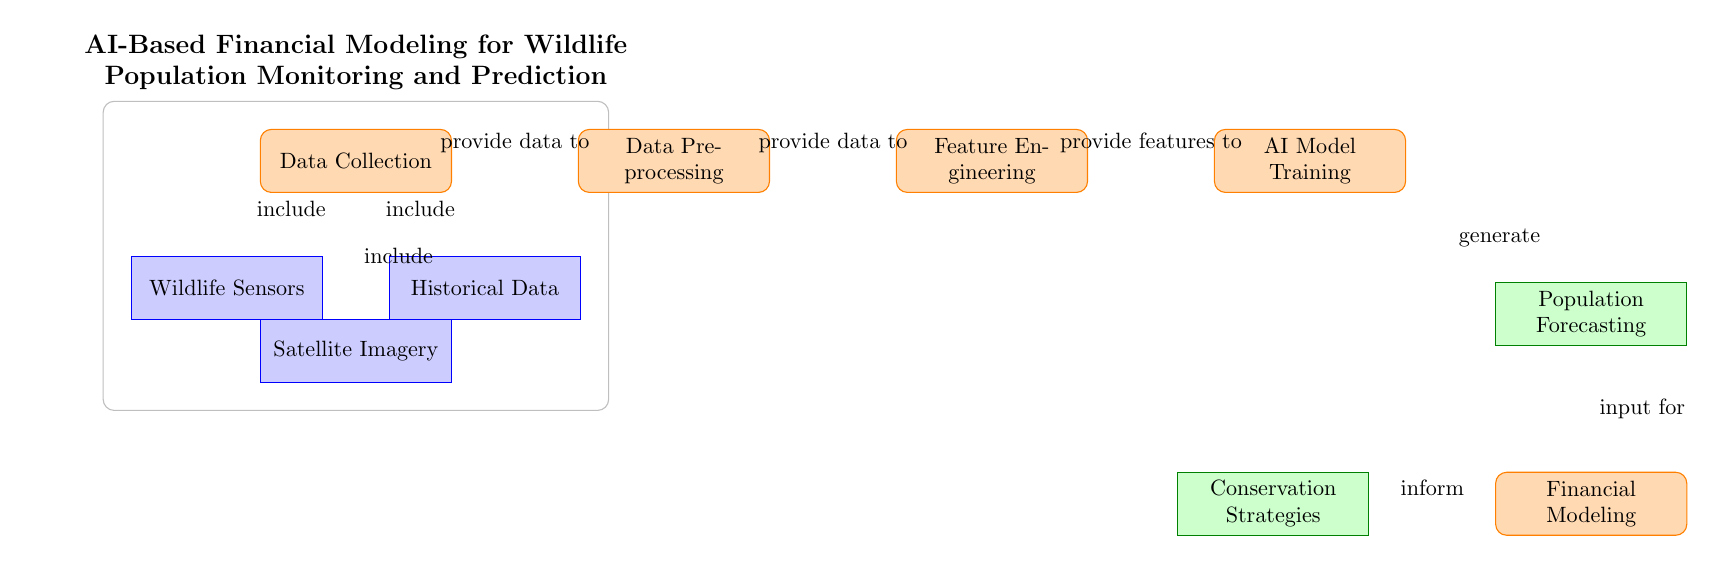What is the first process in the diagram? The first process in the diagram is depicted as a rectangle labeled "Data Collection". This is the first node where data related to wildlife is gathered.
Answer: Data Collection How many data types are included in the Data Collection process? There are three data types included: Wildlife Sensors, Satellite Imagery, and Historical Data. Each of these is connected to the Data Collection process and represents different sources of information.
Answer: Three What does the feature engineering process provide to the AI model training? The feature engineering process provides features, depicted in the diagram as an arrow pointing from Feature Engineering to AI Model Training, indicating that processed data characteristics are fed into the training phase.
Answer: Features What is the output of the AI model training? The output of the AI Model Training is "Population Forecasting", shown in the diagram as the node following the AI Model Training process, indicating the result of the training.
Answer: Population Forecasting What informs the Conservation Strategies process? The Conservation Strategies process is informed by the Financial Modeling output, indicated by the arrow pointing from Financial Modeling to Conservation Strategies. This shows that the insights from financial modeling directly feed into the conservation strategies.
Answer: Financial Modeling What are the two types of outputs in the diagram? The two types of outputs identified in the diagram are "Population Forecasting" and "Conservation Strategies". Both represent the end result of the processes outlined in the diagram, highlighting what is ultimately produced from the initial data collection.
Answer: Population Forecasting and Conservation Strategies Which process comes after Data Preprocessing? The process that comes after Data Preprocessing is Feature Engineering, as shown by the direct arrow connecting the two processes, indicating the sequence of operations performed in the diagram.
Answer: Feature Engineering Which node generates the Population Forecasting? The AI Model Training node generates the Population Forecasting, as the arrow indicates that this is the output produced from the AI Model Training process, representing the forecasting of wildlife populations.
Answer: AI Model Training 